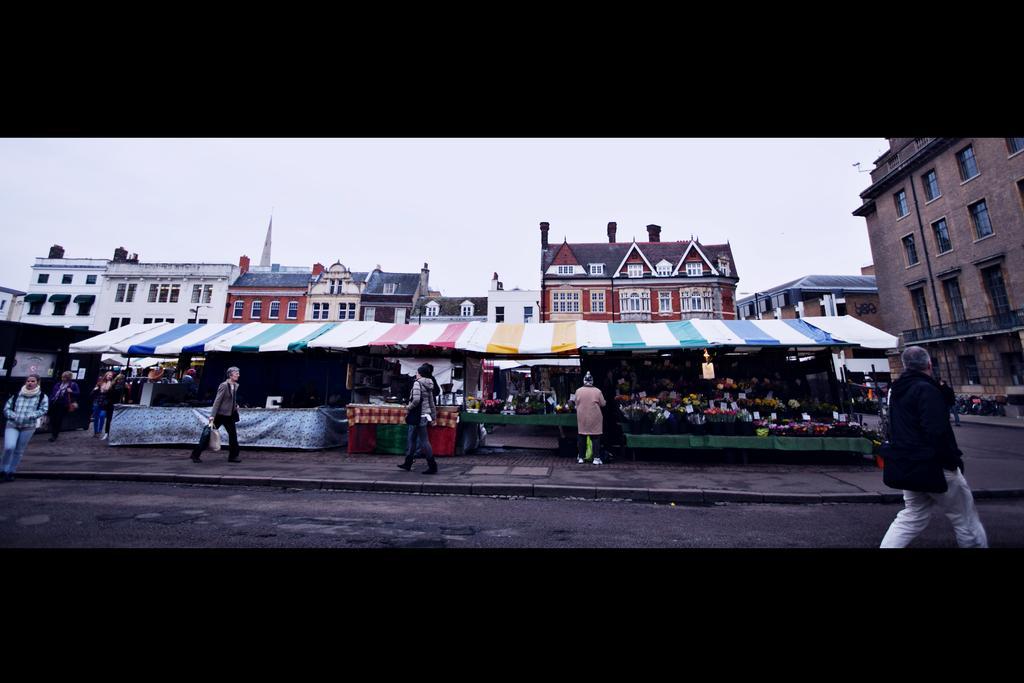How would you summarize this image in a sentence or two? In this image we can see buildings. We can also see the texts. There are people walking on the road. We can see the flower bouquets under the tents. Sky is also visible and the image has borders. 